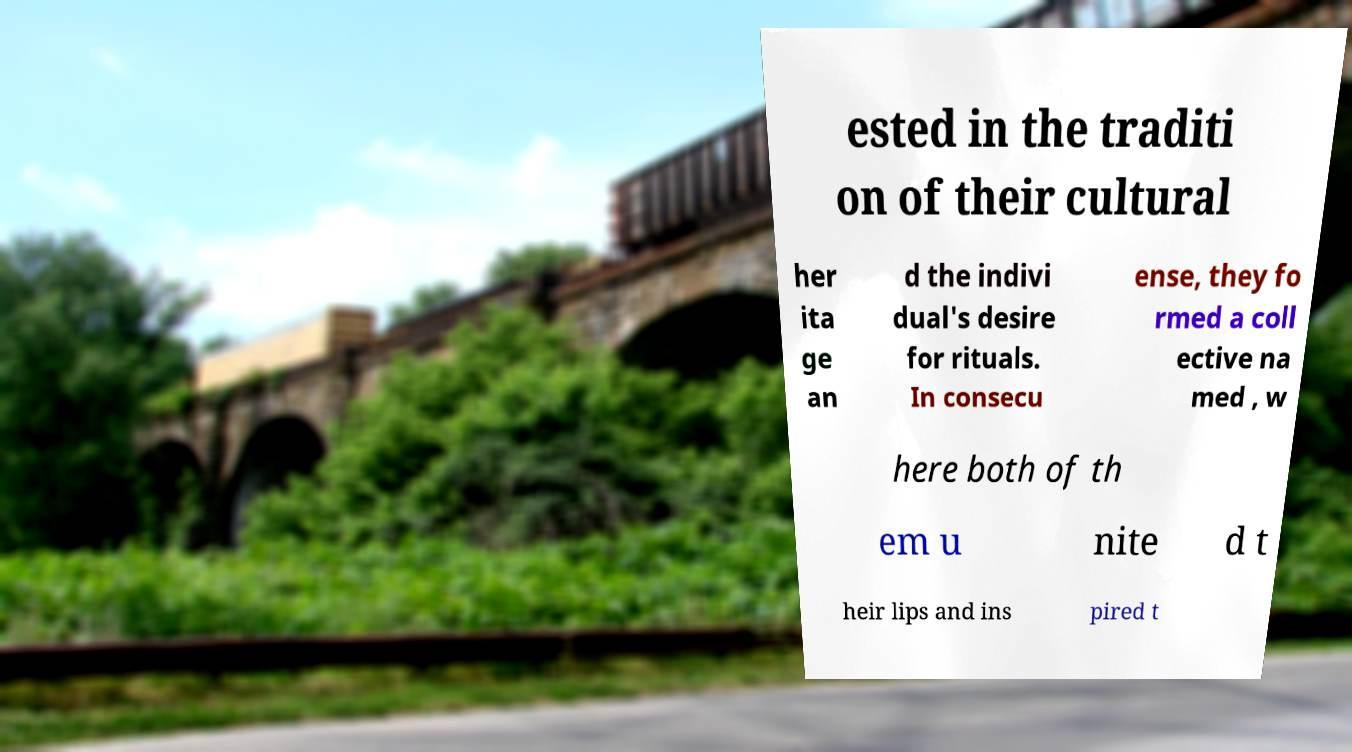I need the written content from this picture converted into text. Can you do that? ested in the traditi on of their cultural her ita ge an d the indivi dual's desire for rituals. In consecu ense, they fo rmed a coll ective na med , w here both of th em u nite d t heir lips and ins pired t 